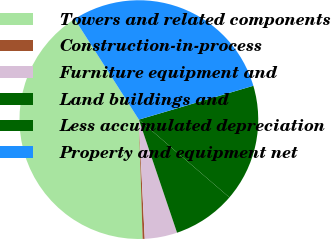Convert chart to OTSL. <chart><loc_0><loc_0><loc_500><loc_500><pie_chart><fcel>Towers and related components<fcel>Construction-in-process<fcel>Furniture equipment and<fcel>Land buildings and<fcel>Less accumulated depreciation<fcel>Property and equipment net<nl><fcel>41.46%<fcel>0.28%<fcel>4.4%<fcel>8.52%<fcel>15.87%<fcel>29.47%<nl></chart> 